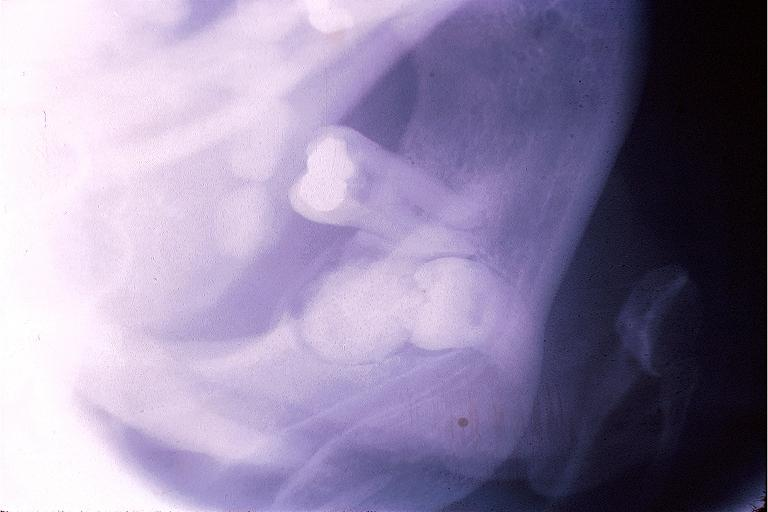what is present?
Answer the question using a single word or phrase. Oral 